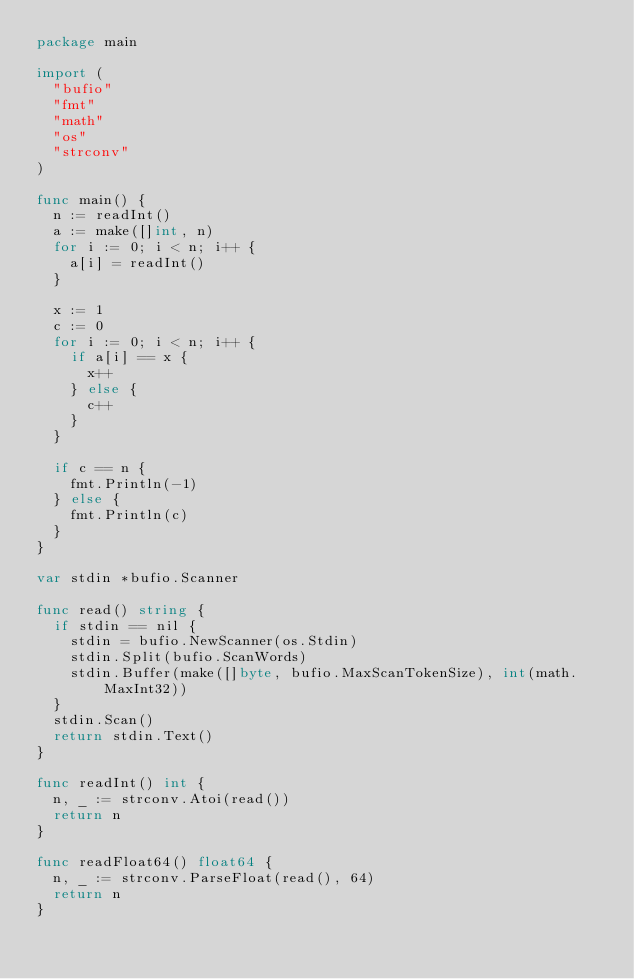Convert code to text. <code><loc_0><loc_0><loc_500><loc_500><_Go_>package main

import (
	"bufio"
	"fmt"
	"math"
	"os"
	"strconv"
)

func main() {
	n := readInt()
	a := make([]int, n)
	for i := 0; i < n; i++ {
		a[i] = readInt()
	}

	x := 1
	c := 0
	for i := 0; i < n; i++ {
		if a[i] == x {
			x++
		} else {
			c++
		}
	}

	if c == n {
		fmt.Println(-1)
	} else {
		fmt.Println(c)
	}
}

var stdin *bufio.Scanner

func read() string {
	if stdin == nil {
		stdin = bufio.NewScanner(os.Stdin)
		stdin.Split(bufio.ScanWords)
		stdin.Buffer(make([]byte, bufio.MaxScanTokenSize), int(math.MaxInt32))
	}
	stdin.Scan()
	return stdin.Text()
}

func readInt() int {
	n, _ := strconv.Atoi(read())
	return n
}

func readFloat64() float64 {
	n, _ := strconv.ParseFloat(read(), 64)
	return n
}
</code> 